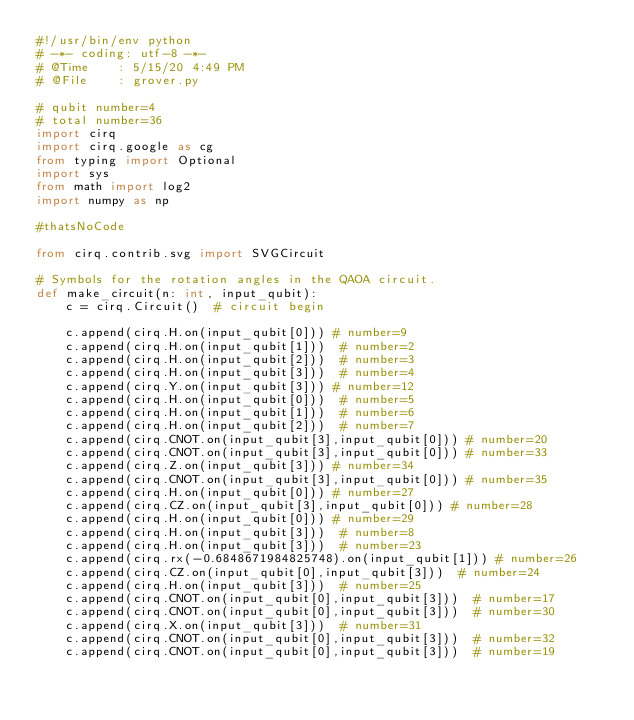Convert code to text. <code><loc_0><loc_0><loc_500><loc_500><_Python_>#!/usr/bin/env python
# -*- coding: utf-8 -*-
# @Time    : 5/15/20 4:49 PM
# @File    : grover.py

# qubit number=4
# total number=36
import cirq
import cirq.google as cg
from typing import Optional
import sys
from math import log2
import numpy as np

#thatsNoCode

from cirq.contrib.svg import SVGCircuit

# Symbols for the rotation angles in the QAOA circuit.
def make_circuit(n: int, input_qubit):
    c = cirq.Circuit()  # circuit begin

    c.append(cirq.H.on(input_qubit[0])) # number=9
    c.append(cirq.H.on(input_qubit[1]))  # number=2
    c.append(cirq.H.on(input_qubit[2]))  # number=3
    c.append(cirq.H.on(input_qubit[3]))  # number=4
    c.append(cirq.Y.on(input_qubit[3])) # number=12
    c.append(cirq.H.on(input_qubit[0]))  # number=5
    c.append(cirq.H.on(input_qubit[1]))  # number=6
    c.append(cirq.H.on(input_qubit[2]))  # number=7
    c.append(cirq.CNOT.on(input_qubit[3],input_qubit[0])) # number=20
    c.append(cirq.CNOT.on(input_qubit[3],input_qubit[0])) # number=33
    c.append(cirq.Z.on(input_qubit[3])) # number=34
    c.append(cirq.CNOT.on(input_qubit[3],input_qubit[0])) # number=35
    c.append(cirq.H.on(input_qubit[0])) # number=27
    c.append(cirq.CZ.on(input_qubit[3],input_qubit[0])) # number=28
    c.append(cirq.H.on(input_qubit[0])) # number=29
    c.append(cirq.H.on(input_qubit[3]))  # number=8
    c.append(cirq.H.on(input_qubit[3]))  # number=23
    c.append(cirq.rx(-0.6848671984825748).on(input_qubit[1])) # number=26
    c.append(cirq.CZ.on(input_qubit[0],input_qubit[3]))  # number=24
    c.append(cirq.H.on(input_qubit[3]))  # number=25
    c.append(cirq.CNOT.on(input_qubit[0],input_qubit[3]))  # number=17
    c.append(cirq.CNOT.on(input_qubit[0],input_qubit[3]))  # number=30
    c.append(cirq.X.on(input_qubit[3]))  # number=31
    c.append(cirq.CNOT.on(input_qubit[0],input_qubit[3]))  # number=32
    c.append(cirq.CNOT.on(input_qubit[0],input_qubit[3]))  # number=19</code> 